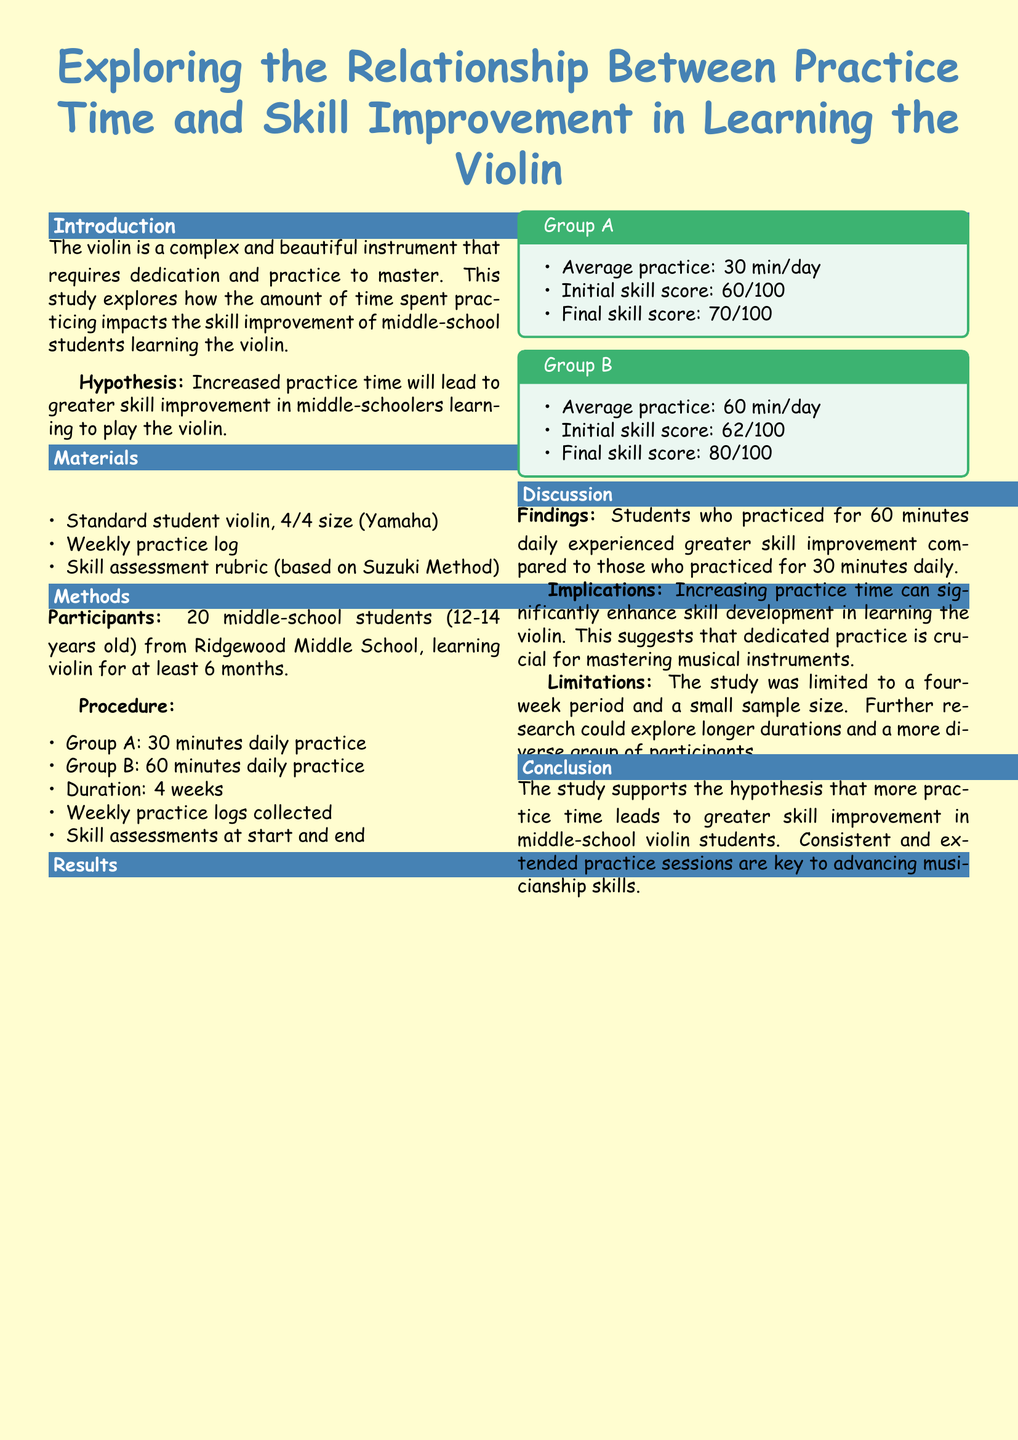What is the hypothesis of the study? The hypothesis is a statement about how practice time will affect skill improvement, specifically that increased practice time will lead to greater skill improvement.
Answer: Increased practice time leads to greater skill improvement What were the initial skill scores of Group A? The initial skill score is provided in the results section for Group A.
Answer: 60/100 How long did the study last? The duration of the study is mentioned under the methods section.
Answer: 4 weeks What is the average practice time for Group B? The average practice time for Group B is specified in the results section.
Answer: 60 min/day What significant finding is discussed in the results? The discussion details the finding regarding the comparison between the two groups in terms of skill improvement.
Answer: Greater skill improvement in Group B What is a limitation mentioned in the report? The document identifies a limitation in the study's methodology or scope.
Answer: Small sample size What assessment method was used for skill evaluation? The type of assessment method used for evaluating skills is indicated in the materials section.
Answer: Suzuki Method What is the final skill score for Group B? The document provides the final skill score for Group B in the results section.
Answer: 80/100 What conclusion is drawn from the study? The conclusion summarizes the findings regarding the relationship between practice time and skill improvement.
Answer: More practice time leads to greater skill improvement 